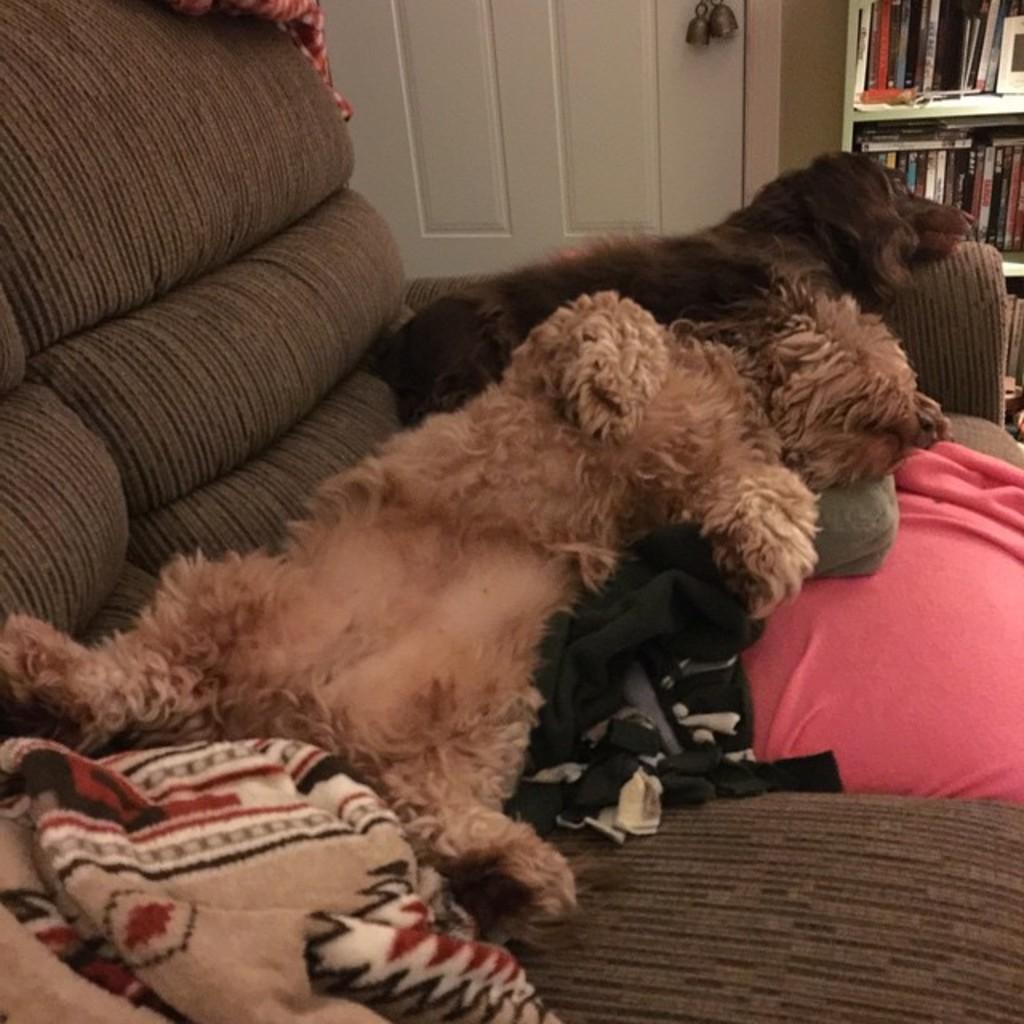Describe this image in one or two sentences. In this image I can see a couch which is brown and black in color. On the couch I can see two dogs which are brown and black in color, few clothes and few other objects. In the background I can see a bookshelf with few books in it and a white colored door. 